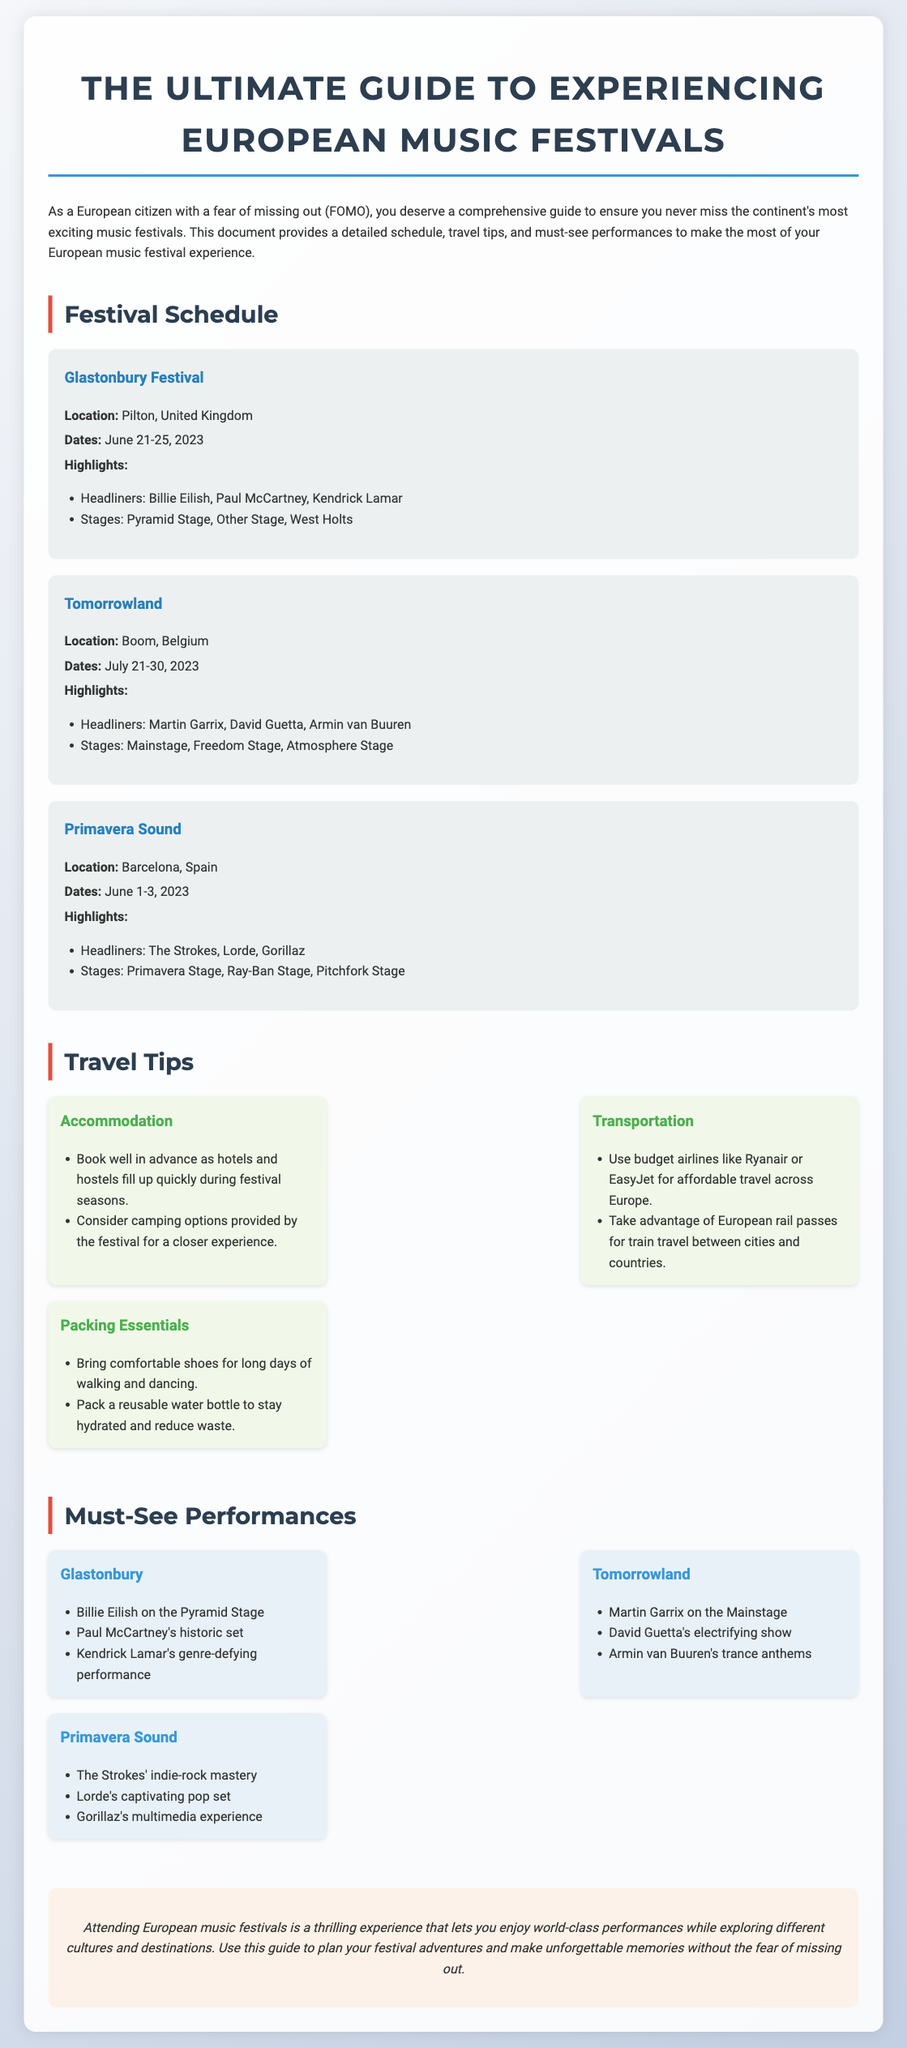What are the dates for Glastonbury Festival? The dates for Glastonbury Festival are highlighted in the document under the festival details section.
Answer: June 21-25, 2023 Who is headlining Tomorrowland? The headliners for Tomorrowland are specified in the highlights section of the festival.
Answer: Martin Garrix, David Guetta, Armin van Buuren What general advice is given for accommodation? The document provides travel tips, including advice on accommodation options during festivals.
Answer: Book well in advance Which performance is noted as historic? The document describes specific performances at festivals, highlighting unique attributes.
Answer: Paul McCartney's historic set How many music festivals are listed in the document? By counting the festivals presented in the schedule section, the total can be derived.
Answer: Three What type of travel options are suggested for convenience? The travel tips section discusses modes of transportation for festival attendees.
Answer: Budget airlines Which Spanish city is hosting Primavera Sound? The location of each festival is provided in the festival schedule section, detailing where they take place.
Answer: Barcelona What is recommended to pack for hydration? The packing essentials highlighted in the travel tips give advice on necessary items for festival-goers.
Answer: Reusable water bottle 